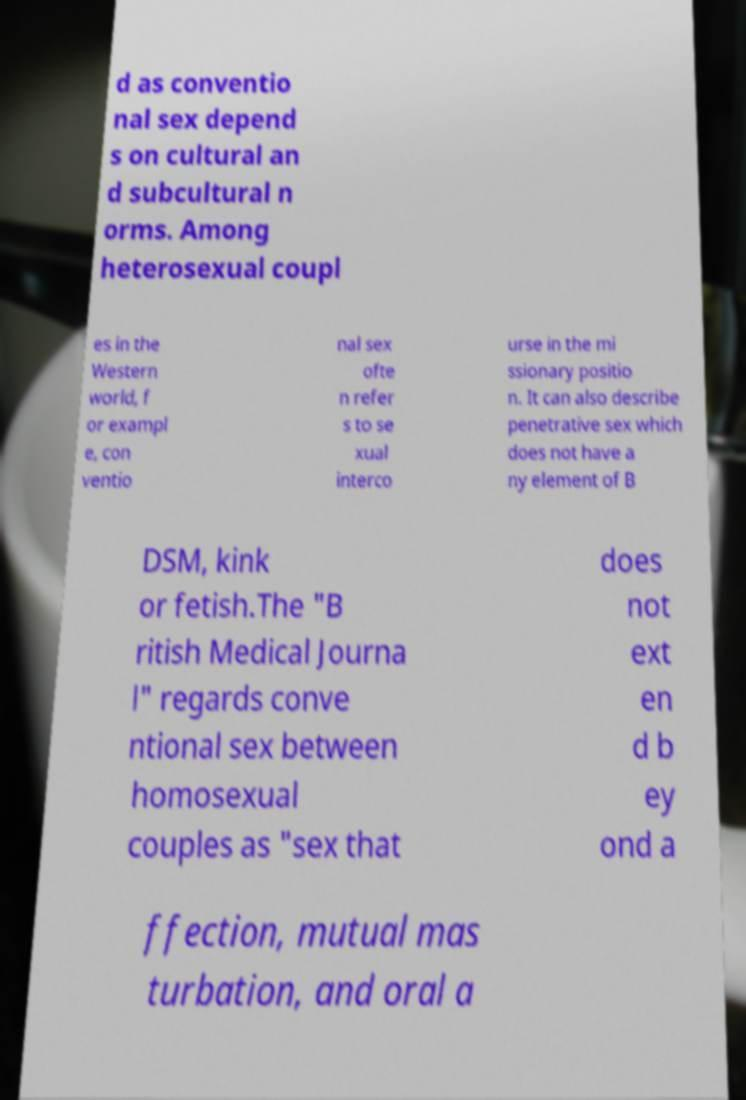Could you assist in decoding the text presented in this image and type it out clearly? d as conventio nal sex depend s on cultural an d subcultural n orms. Among heterosexual coupl es in the Western world, f or exampl e, con ventio nal sex ofte n refer s to se xual interco urse in the mi ssionary positio n. It can also describe penetrative sex which does not have a ny element of B DSM, kink or fetish.The "B ritish Medical Journa l" regards conve ntional sex between homosexual couples as "sex that does not ext en d b ey ond a ffection, mutual mas turbation, and oral a 